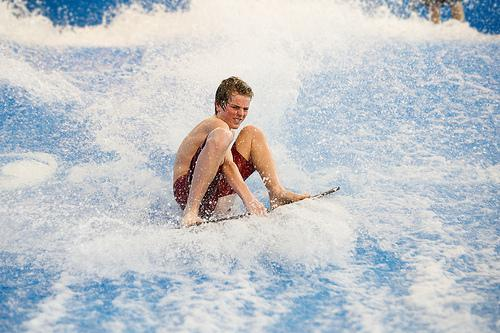Question: who is on the surfboard?
Choices:
A. Dog.
B. Child.
C. Man.
D. Boy.
Answer with the letter. Answer: D Question: what gender is the person in the water?
Choices:
A. Female.
B. Child.
C. Male.
D. Baby.
Answer with the letter. Answer: C Question: what is the person doing?
Choices:
A. Surfing.
B. Skating.
C. Roller blading.
D. Running.
Answer with the letter. Answer: A 